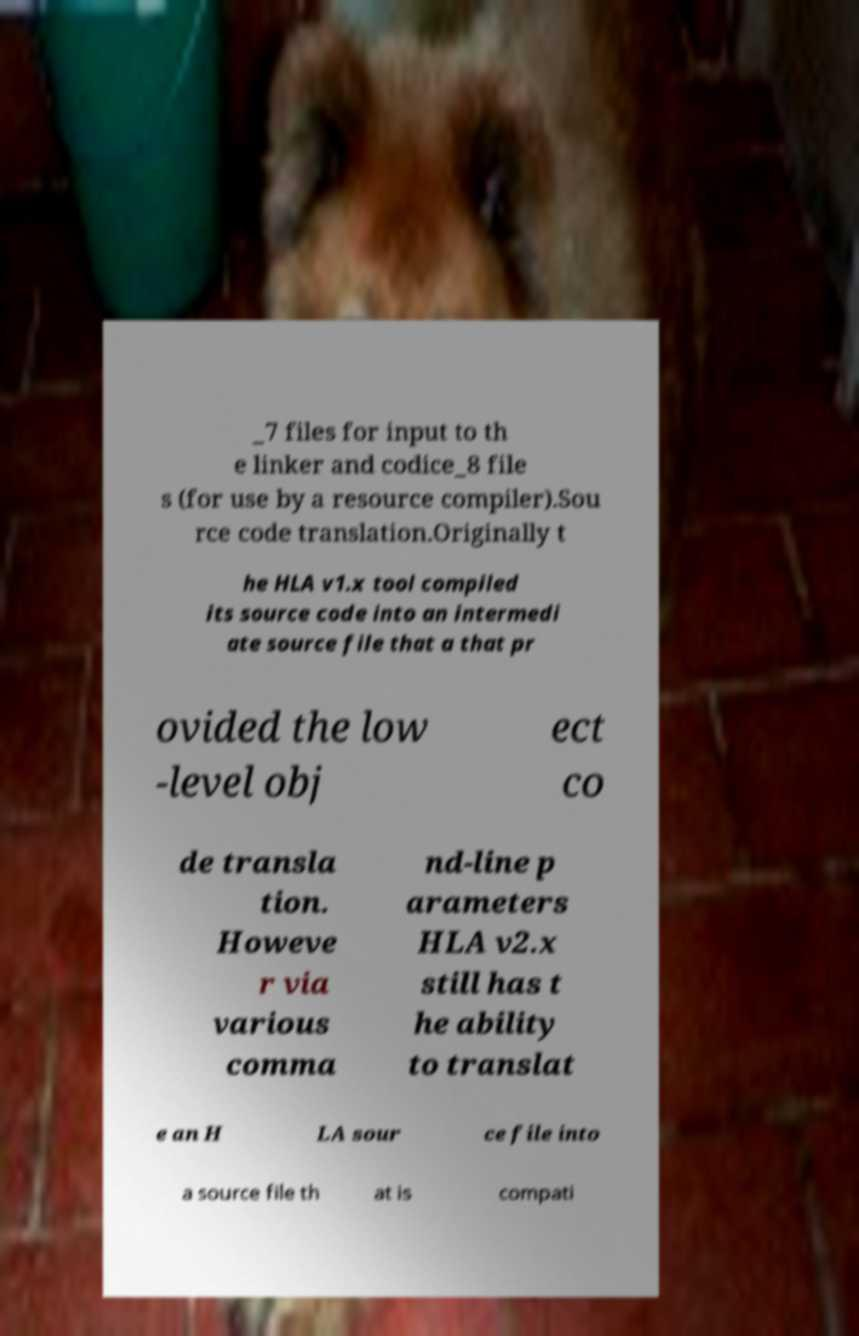Can you read and provide the text displayed in the image?This photo seems to have some interesting text. Can you extract and type it out for me? _7 files for input to th e linker and codice_8 file s (for use by a resource compiler).Sou rce code translation.Originally t he HLA v1.x tool compiled its source code into an intermedi ate source file that a that pr ovided the low -level obj ect co de transla tion. Howeve r via various comma nd-line p arameters HLA v2.x still has t he ability to translat e an H LA sour ce file into a source file th at is compati 